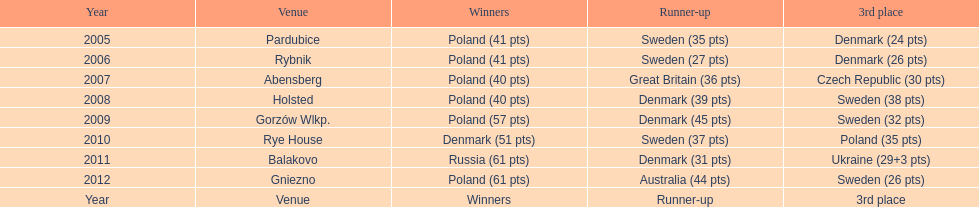What was the ultimate year that a 3rd place finish resulted in less than 25 points? 2005. 